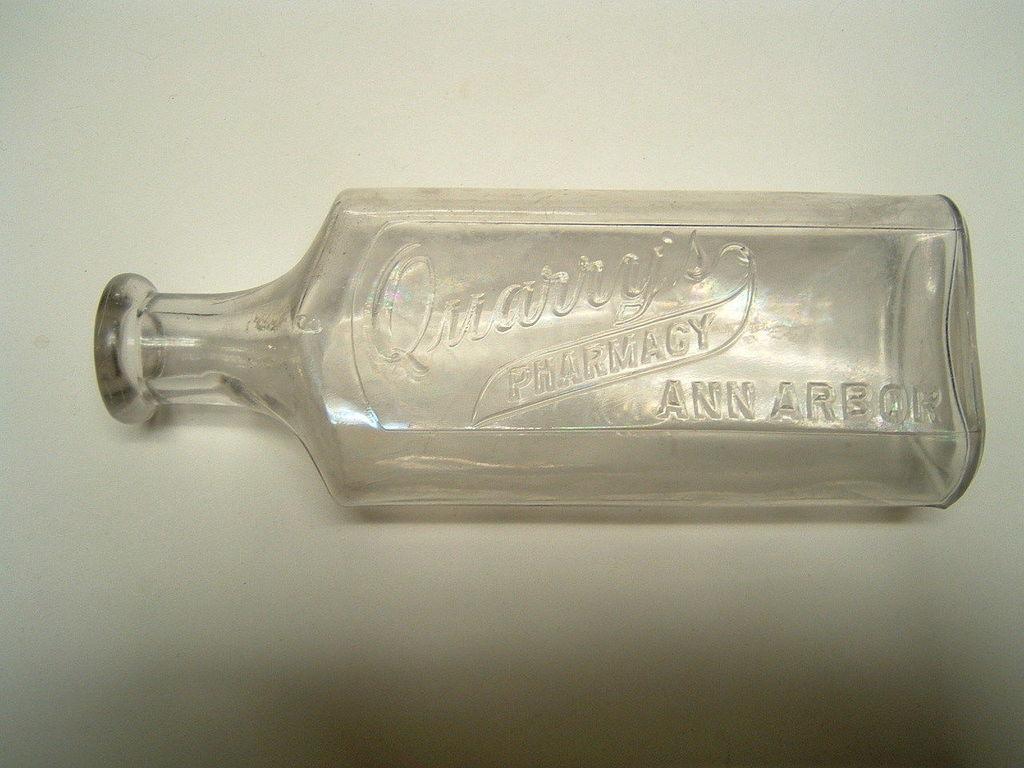In one or two sentences, can you explain what this image depicts? In the image there is a glass bottle on which it is written as pharmacy and the background is in white color. 